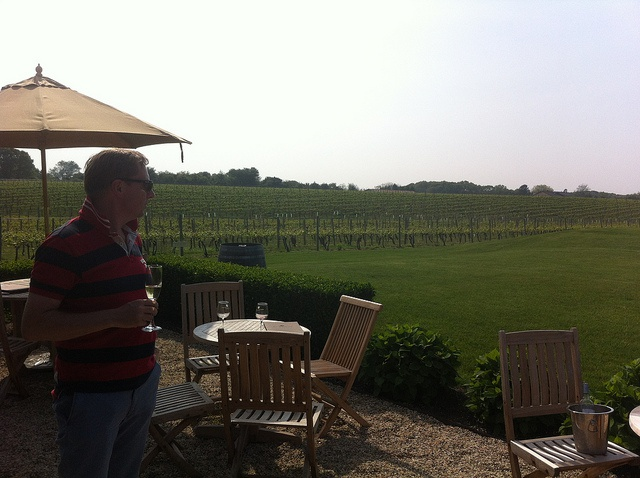Describe the objects in this image and their specific colors. I can see people in white, black, gray, and darkgray tones, chair in ivory, black, and gray tones, chair in ivory, black, and gray tones, umbrella in ivory, tan, and black tones, and chair in white, black, maroon, and gray tones in this image. 